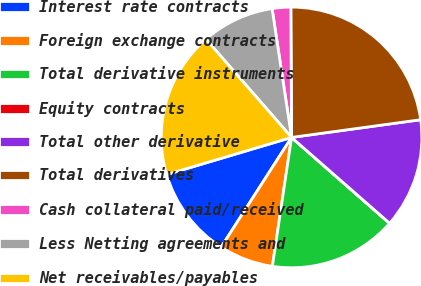<chart> <loc_0><loc_0><loc_500><loc_500><pie_chart><fcel>Interest rate contracts<fcel>Foreign exchange contracts<fcel>Total derivative instruments<fcel>Equity contracts<fcel>Total other derivative<fcel>Total derivatives<fcel>Cash collateral paid/received<fcel>Less Netting agreements and<fcel>Net receivables/payables<nl><fcel>11.32%<fcel>6.73%<fcel>15.9%<fcel>0.01%<fcel>13.61%<fcel>22.92%<fcel>2.3%<fcel>9.02%<fcel>18.19%<nl></chart> 